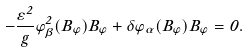Convert formula to latex. <formula><loc_0><loc_0><loc_500><loc_500>- \frac { \varepsilon ^ { 2 } } { g } \varphi _ { \beta } ^ { 2 } ( B _ { \varphi } ) B _ { \varphi } + \delta \varphi _ { \alpha } ( B _ { \varphi } ) B _ { \varphi } = 0 .</formula> 